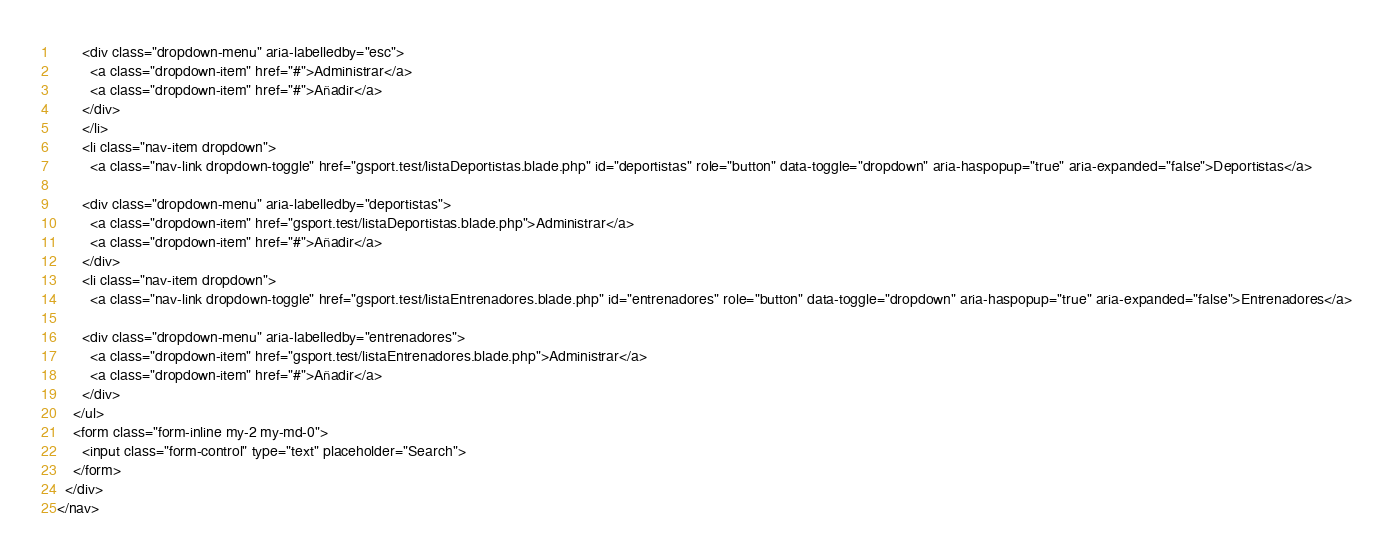<code> <loc_0><loc_0><loc_500><loc_500><_PHP_>      <div class="dropdown-menu" aria-labelledby="esc">
        <a class="dropdown-item" href="#">Administrar</a>
        <a class="dropdown-item" href="#">Añadir</a>
      </div>
      </li>
      <li class="nav-item dropdown">
        <a class="nav-link dropdown-toggle" href="gsport.test/listaDeportistas.blade.php" id="deportistas" role="button" data-toggle="dropdown" aria-haspopup="true" aria-expanded="false">Deportistas</a>
      
      <div class="dropdown-menu" aria-labelledby="deportistas">
        <a class="dropdown-item" href="gsport.test/listaDeportistas.blade.php">Administrar</a>
        <a class="dropdown-item" href="#">Añadir</a>
      </div>
      <li class="nav-item dropdown">
        <a class="nav-link dropdown-toggle" href="gsport.test/listaEntrenadores.blade.php" id="entrenadores" role="button" data-toggle="dropdown" aria-haspopup="true" aria-expanded="false">Entrenadores</a>
      
      <div class="dropdown-menu" aria-labelledby="entrenadores">
        <a class="dropdown-item" href="gsport.test/listaEntrenadores.blade.php">Administrar</a>
        <a class="dropdown-item" href="#">Añadir</a>
      </div>
    </ul>
    <form class="form-inline my-2 my-md-0">
      <input class="form-control" type="text" placeholder="Search">
    </form>
  </div>
</nav></code> 